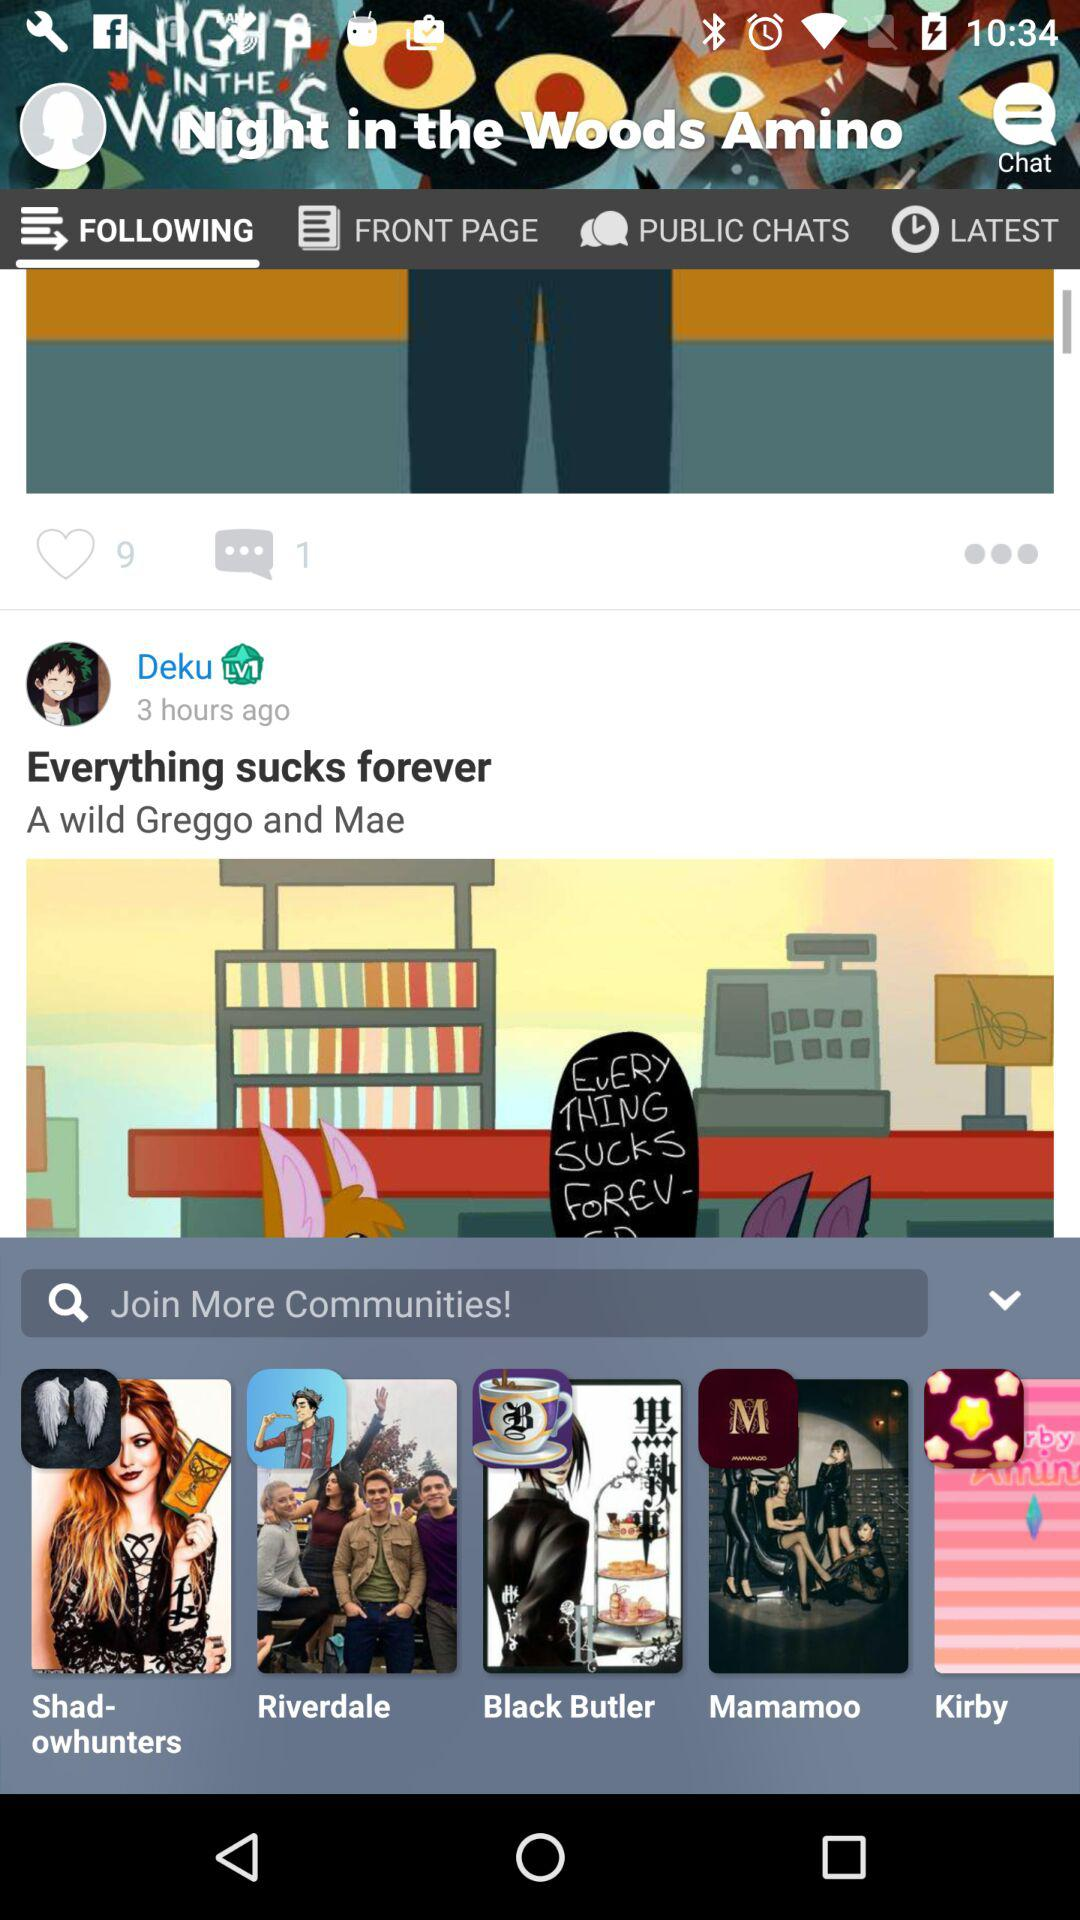How many comments are there on the post? There is 1 comment on the post. 